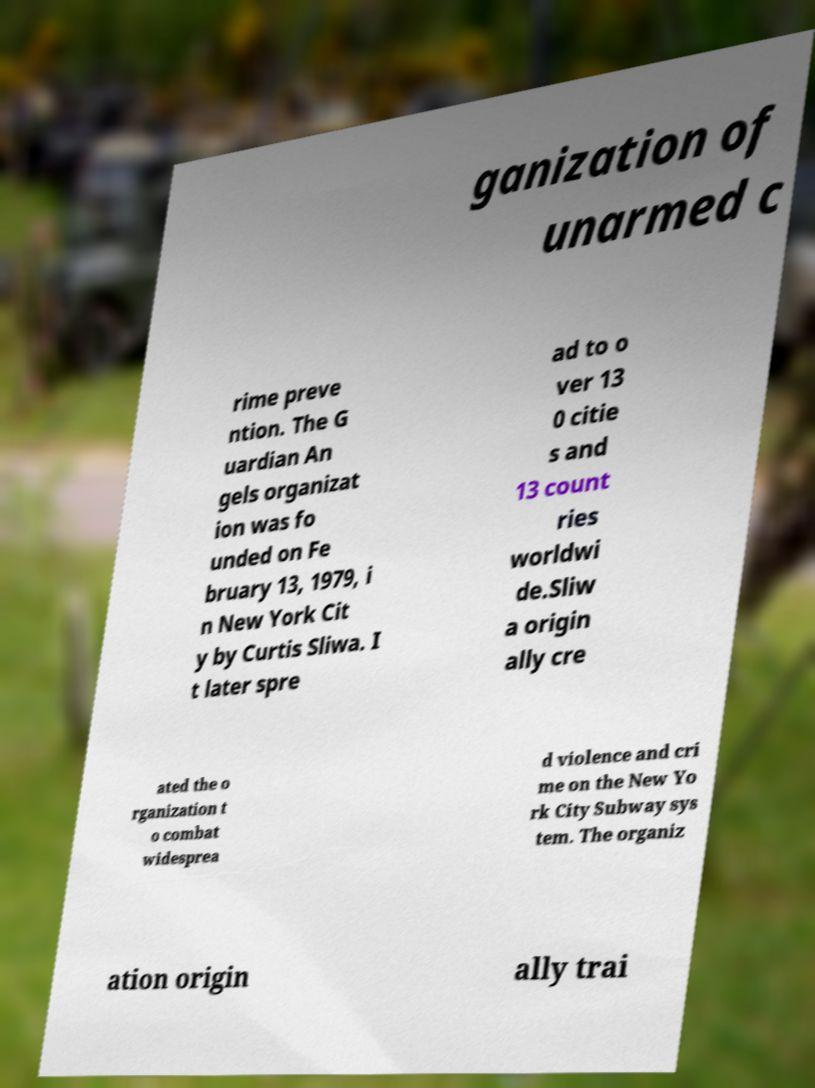Could you extract and type out the text from this image? ganization of unarmed c rime preve ntion. The G uardian An gels organizat ion was fo unded on Fe bruary 13, 1979, i n New York Cit y by Curtis Sliwa. I t later spre ad to o ver 13 0 citie s and 13 count ries worldwi de.Sliw a origin ally cre ated the o rganization t o combat widesprea d violence and cri me on the New Yo rk City Subway sys tem. The organiz ation origin ally trai 